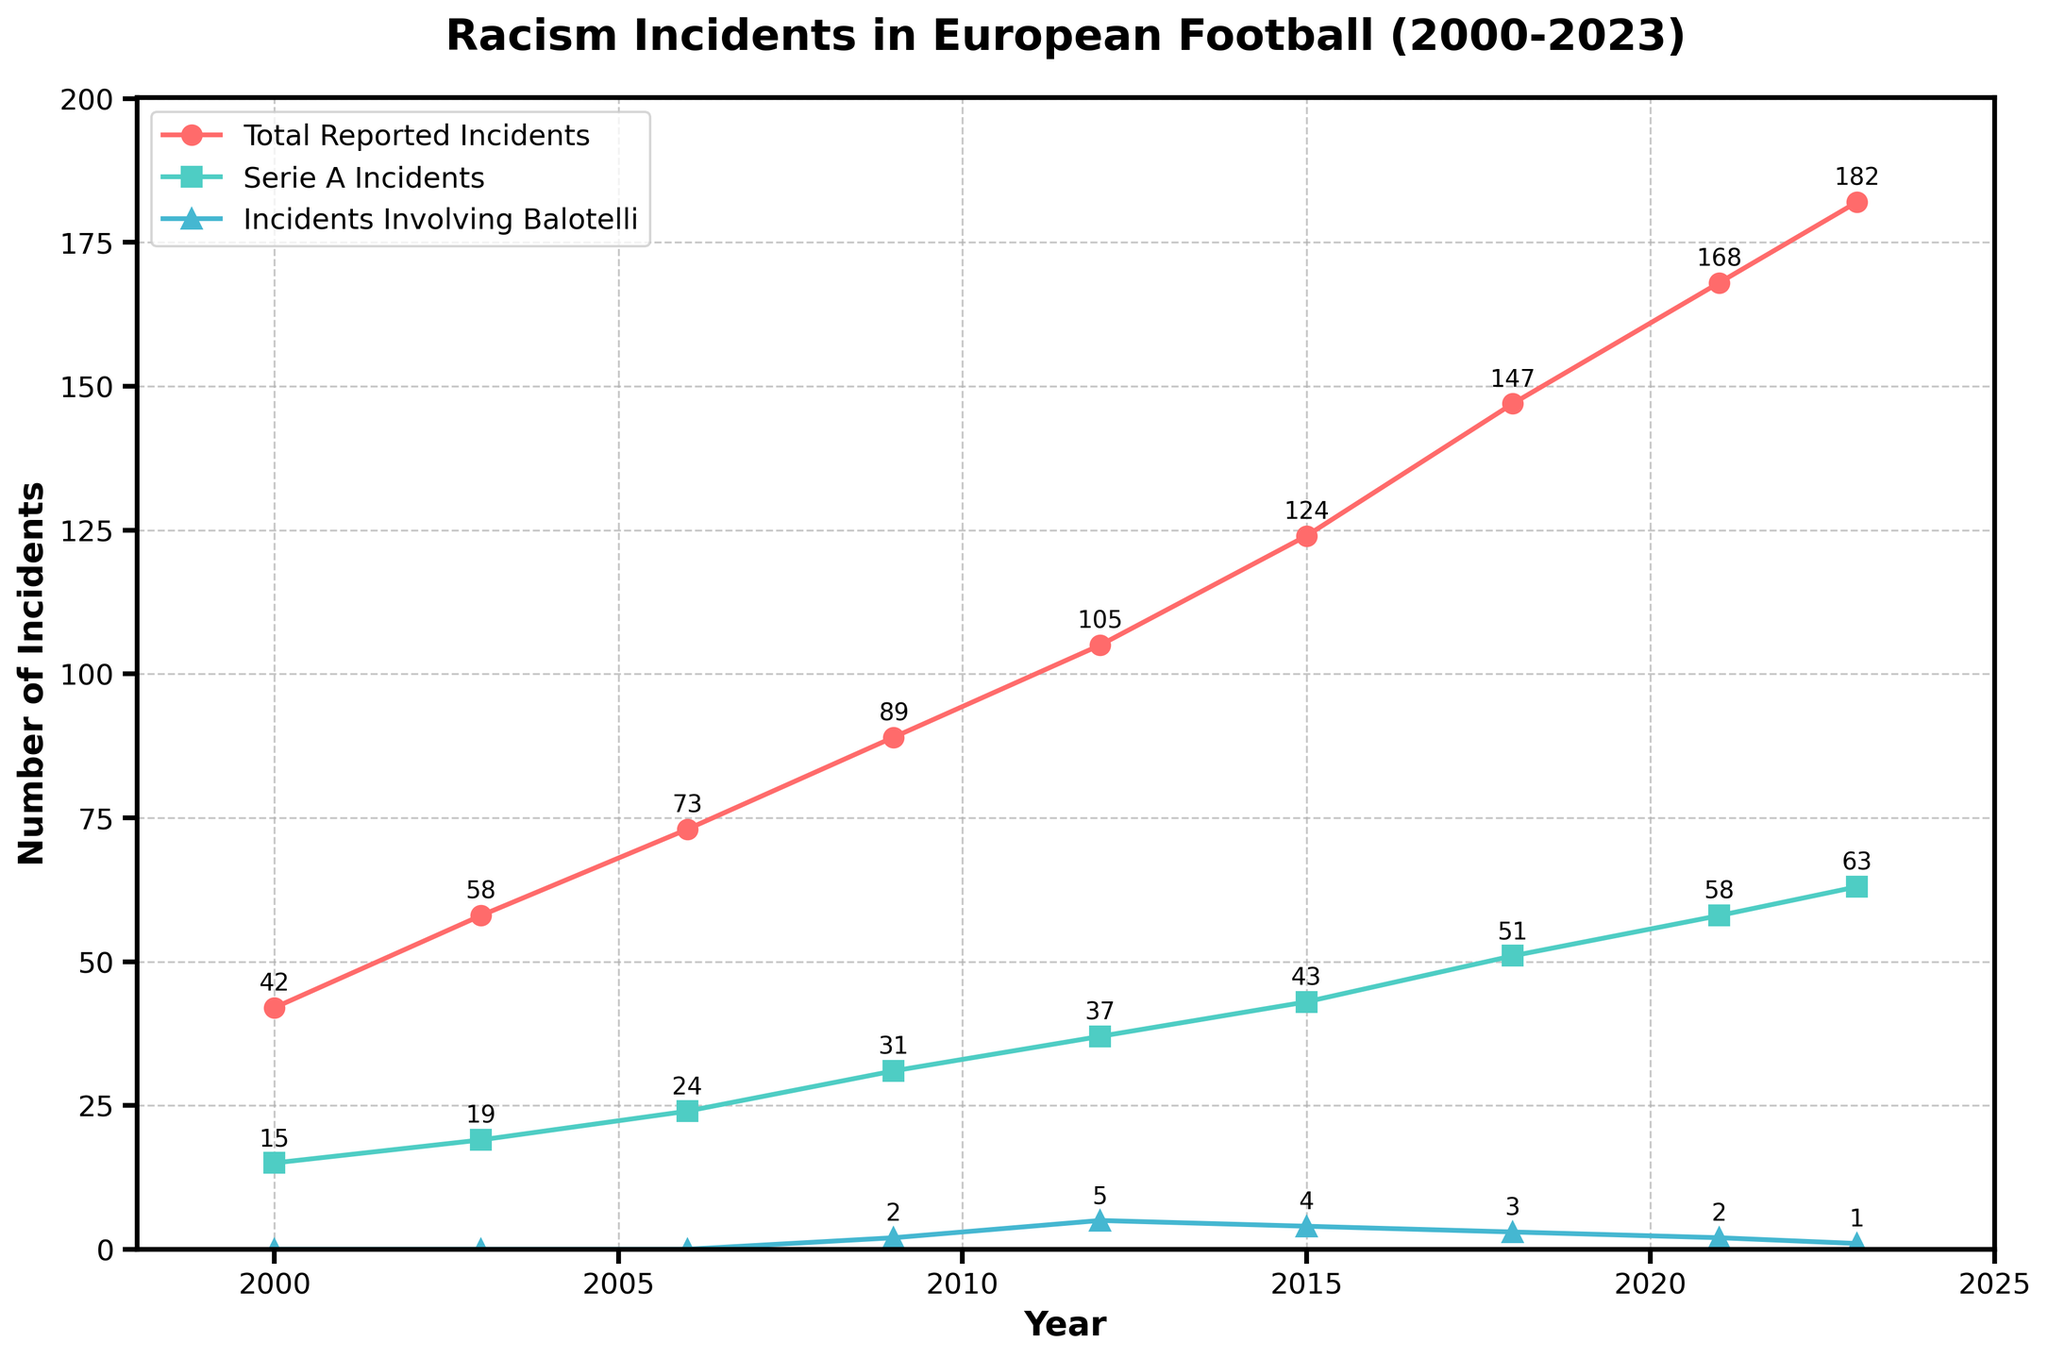What is the trend of total reported racism incidents from 2000 to 2023? Observing the plot, the total reported racism incidents increase consistently from 42 in 2000 to 182 in 2023.
Answer: Increasing trend Which year had the highest number of Serie A incidents? In the plot, the highest point for Serie A incidents (green line) is at the year 2023 with 63 incidents.
Answer: 2023 What is the difference between the total reported incidents and Serie A incidents in 2021? In 2021, the total reported incidents are 168 and Serie A incidents are 58. The difference is 168 - 58 = 110.
Answer: 110 How many incidents involving Balotelli were reported in 2009? Observing the plot, the blue line with triangles (Incidents Involving Balotelli) shows 2 incidents in 2009.
Answer: 2 Compared to 2012, how many more total incidents were reported in 2015? In 2012, total reported incidents are 105. In 2015, they are 124. The difference is 124 - 105 = 19.
Answer: 19 In which year did the incidents involving Balotelli peak? Observing the blue triangles on the plot, the peak (maximum) occurs in 2012 with 5 incidents.
Answer: 2012 What is the ratio of Serie A incidents to total reported incidents in 2018? In 2018, Serie A incidents are 51 and total reported incidents are 147. The ratio is 51 / 147 ≈ 0.35.
Answer: 0.35 What visual cues indicate the general trend of incidents involving Balotelli? The blue triangles representing incidents involving Balotelli generally decrease in frequency over the years from 2009 to 2023.
Answer: Decreasing trend How does the number of total reported incidents in 2023 compare to 2000? In 2023, there are 182 total reported incidents, while in 2000 there were 42. Comparing them, 182 > 42, indicating a significant increase.
Answer: Significant increase Which category of incidents sees the steepest increase overall, and how can you tell? The red line representing total reported incidents shows the steepest upward slope, indicating the most significant increase overall.
Answer: Total reported incidents 